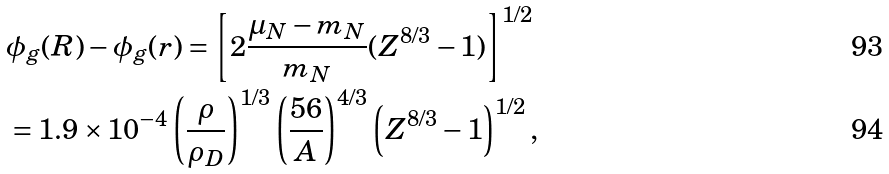<formula> <loc_0><loc_0><loc_500><loc_500>& \phi _ { g } ( R ) - \phi _ { g } ( r ) = \left [ 2 \frac { \mu _ { N } - m _ { N } } { m _ { N } } ( Z ^ { 8 / 3 } - 1 ) \right ] ^ { 1 / 2 } \\ & = 1 . 9 \times 1 0 ^ { - 4 } \left ( \frac { \rho } { \rho _ { D } } \right ) ^ { 1 / 3 } \left ( \frac { 5 6 } { A } \right ) ^ { 4 / 3 } \left ( Z ^ { 8 / 3 } - 1 \right ) ^ { 1 / 2 } ,</formula> 